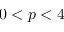<formula> <loc_0><loc_0><loc_500><loc_500>0 < p < 4</formula> 